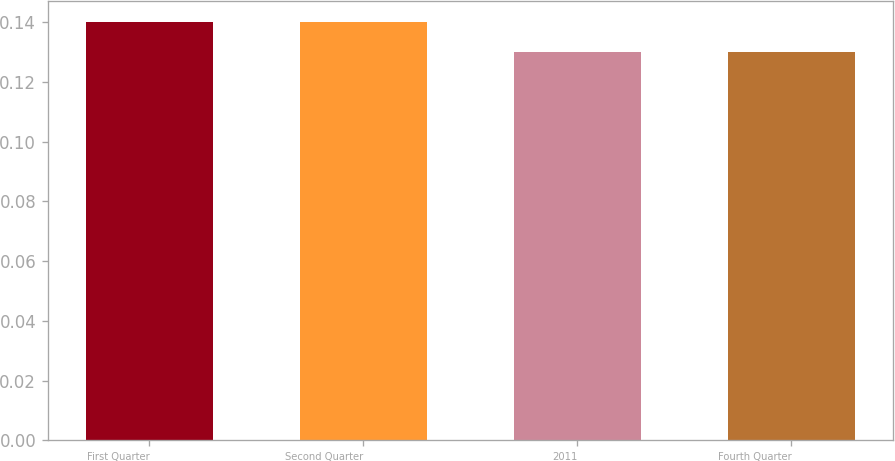Convert chart. <chart><loc_0><loc_0><loc_500><loc_500><bar_chart><fcel>First Quarter<fcel>Second Quarter<fcel>2011<fcel>Fourth Quarter<nl><fcel>0.14<fcel>0.14<fcel>0.13<fcel>0.13<nl></chart> 